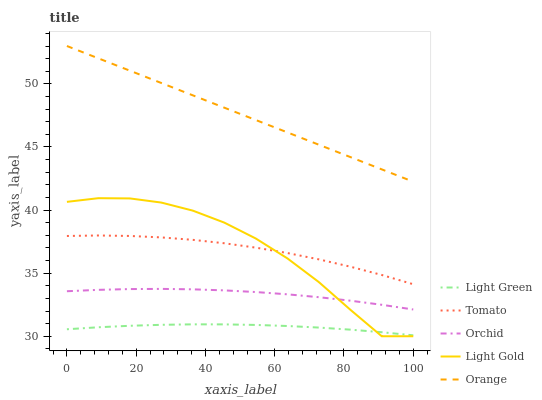Does Light Green have the minimum area under the curve?
Answer yes or no. Yes. Does Orange have the maximum area under the curve?
Answer yes or no. Yes. Does Light Gold have the minimum area under the curve?
Answer yes or no. No. Does Light Gold have the maximum area under the curve?
Answer yes or no. No. Is Orange the smoothest?
Answer yes or no. Yes. Is Light Gold the roughest?
Answer yes or no. Yes. Is Light Gold the smoothest?
Answer yes or no. No. Is Orange the roughest?
Answer yes or no. No. Does Orange have the lowest value?
Answer yes or no. No. Does Light Gold have the highest value?
Answer yes or no. No. Is Light Gold less than Orange?
Answer yes or no. Yes. Is Orchid greater than Light Green?
Answer yes or no. Yes. Does Light Gold intersect Orange?
Answer yes or no. No. 